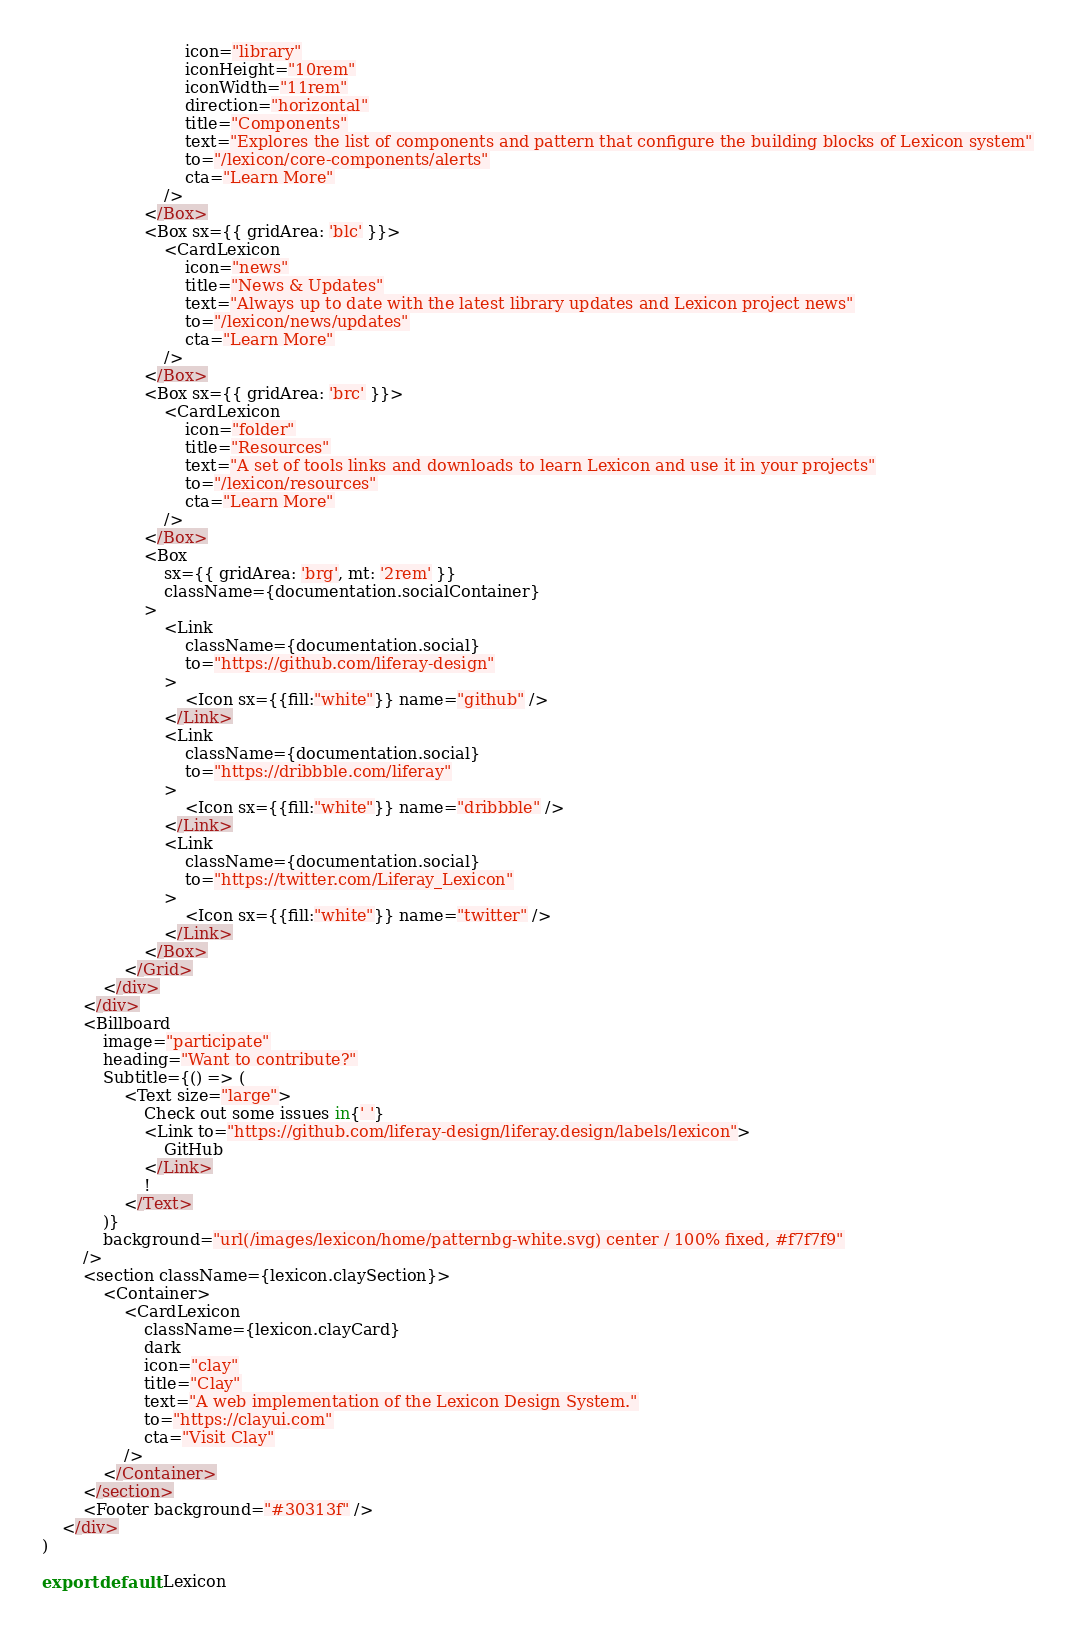<code> <loc_0><loc_0><loc_500><loc_500><_JavaScript_>							icon="library"
							iconHeight="10rem"
							iconWidth="11rem"
							direction="horizontal"
							title="Components"
							text="Explores the list of components and pattern that configure the building blocks of Lexicon system"
							to="/lexicon/core-components/alerts"
							cta="Learn More"
						/>
					</Box>
					<Box sx={{ gridArea: 'blc' }}>
						<CardLexicon
							icon="news"
							title="News & Updates"
							text="Always up to date with the latest library updates and Lexicon project news"
							to="/lexicon/news/updates"
							cta="Learn More"
						/>
					</Box>
					<Box sx={{ gridArea: 'brc' }}>
						<CardLexicon
							icon="folder"
							title="Resources"
							text="A set of tools links and downloads to learn Lexicon and use it in your projects"
							to="/lexicon/resources"
							cta="Learn More"
						/>
					</Box>
					<Box
						sx={{ gridArea: 'brg', mt: '2rem' }}
						className={documentation.socialContainer}
					>
						<Link
							className={documentation.social}
							to="https://github.com/liferay-design"
						>
							<Icon sx={{fill:"white"}} name="github" />
						</Link>
						<Link
							className={documentation.social}
							to="https://dribbble.com/liferay"
						>
							<Icon sx={{fill:"white"}} name="dribbble" />
						</Link>
						<Link
							className={documentation.social}
							to="https://twitter.com/Liferay_Lexicon"
						>
							<Icon sx={{fill:"white"}} name="twitter" />
						</Link>
					</Box>
				</Grid>
			</div>
		</div>
		<Billboard
			image="participate"
			heading="Want to contribute?"
			Subtitle={() => (
				<Text size="large">
					Check out some issues in{' '}
					<Link to="https://github.com/liferay-design/liferay.design/labels/lexicon">
						GitHub
					</Link>
					!
				</Text>
			)}
			background="url(/images/lexicon/home/patternbg-white.svg) center / 100% fixed, #f7f7f9"
		/>
		<section className={lexicon.claySection}>
			<Container>
				<CardLexicon
					className={lexicon.clayCard}
					dark
					icon="clay"
					title="Clay"
					text="A web implementation of the Lexicon Design System."
					to="https://clayui.com"
					cta="Visit Clay"
				/>
			</Container>
		</section>
		<Footer background="#30313f" />
	</div>
)

export default Lexicon
</code> 